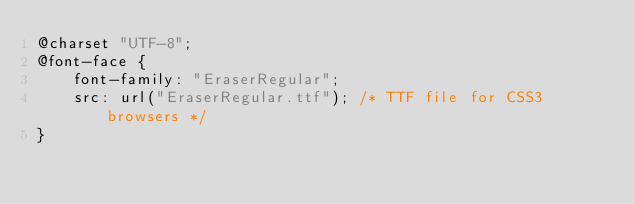<code> <loc_0><loc_0><loc_500><loc_500><_CSS_>@charset "UTF-8";
@font-face {
    font-family: "EraserRegular";
  	src: url("EraserRegular.ttf"); /* TTF file for CSS3 browsers */
}</code> 